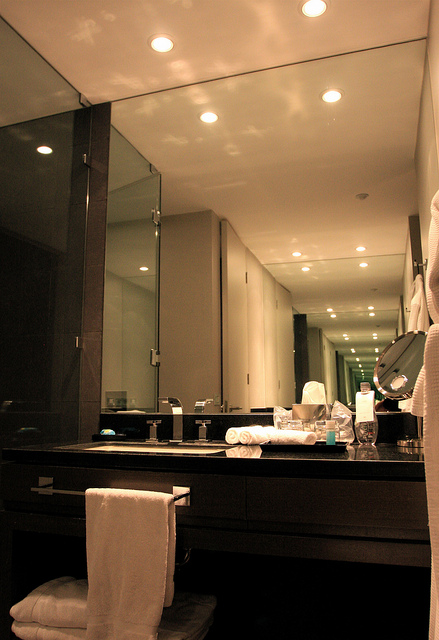Imagine there is a hidden door in this bathroom. Where might it lead? Imagine discovering a hidden door seamlessly integrated into the design of this bathroom. This door could be concealed behind the large mirror, which slides open gently to reveal a luxurious private spa. This secret room could feature a hot tub, a sauna, and a steam room, providing the ultimate relaxation retreat. The space might be adorned with ambient lighting, aromatic candles, and soothing music, enhancing the spa-like experience. The addition of such a hidden room would elevate this bathroom from a simple functional space to an exclusive sanctuary for unwinding and indulgence. What practical additions could enhance this bathroom for daily use? For daily use, practical additions such as a magnifying mirror for detailed grooming tasks, built-in storage solutions to keep toiletries organized, and a heated towel rack for added comfort could enhance this bathroom. Additionally, installing a shower bench and grab bars could improve safety and accessibility for all users. These features would not only add convenience but also elevate the overall functionality and user experience of the bathroom. 